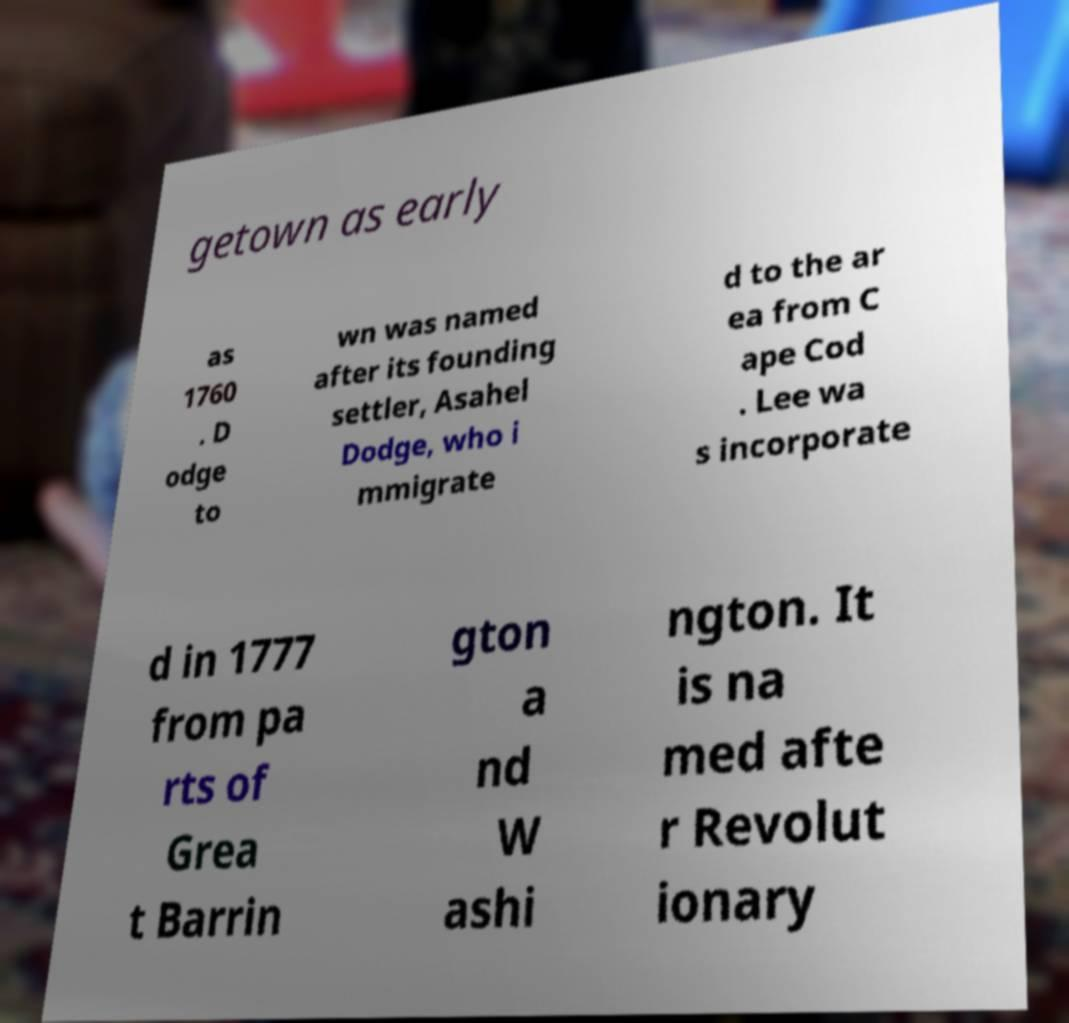I need the written content from this picture converted into text. Can you do that? getown as early as 1760 . D odge to wn was named after its founding settler, Asahel Dodge, who i mmigrate d to the ar ea from C ape Cod . Lee wa s incorporate d in 1777 from pa rts of Grea t Barrin gton a nd W ashi ngton. It is na med afte r Revolut ionary 